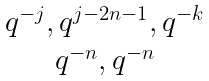<formula> <loc_0><loc_0><loc_500><loc_500>\begin{matrix} q ^ { - j } , q ^ { j - 2 n - 1 } , q ^ { - k } \\ q ^ { - n } , q ^ { - n } \end{matrix}</formula> 